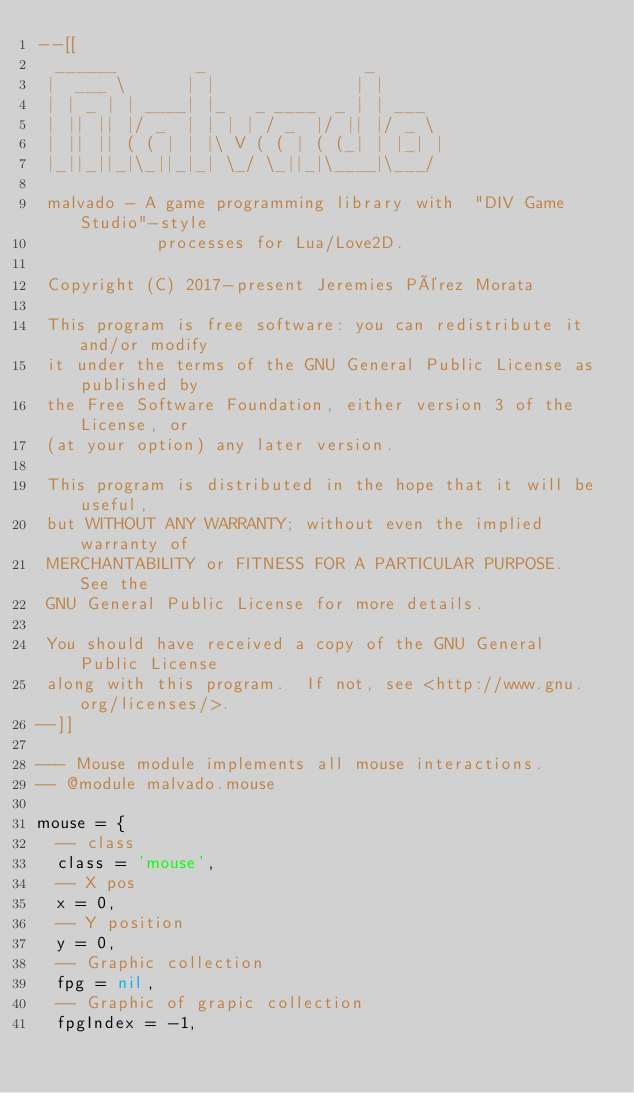<code> <loc_0><loc_0><loc_500><loc_500><_Lua_>--[[
  ______        _                _
 |  ___ \      | |              | |
 | | _ | | ____| |_   _ ____  _ | | ___
 | || || |/ _  | | | | / _  |/ || |/ _ \
 | || || ( ( | | |\ V ( ( | ( (_| | |_| |
 |_||_||_|\_||_|_| \_/ \_||_|\____|\___/

 malvado - A game programming library with  "DIV Game Studio"-style
            processes for Lua/Love2D.

 Copyright (C) 2017-present Jeremies Pérez Morata

 This program is free software: you can redistribute it and/or modify
 it under the terms of the GNU General Public License as published by
 the Free Software Foundation, either version 3 of the License, or
 (at your option) any later version.

 This program is distributed in the hope that it will be useful,
 but WITHOUT ANY WARRANTY; without even the implied warranty of
 MERCHANTABILITY or FITNESS FOR A PARTICULAR PURPOSE.  See the
 GNU General Public License for more details.

 You should have received a copy of the GNU General Public License
 along with this program.  If not, see <http://www.gnu.org/licenses/>.
--]]

--- Mouse module implements all mouse interactions.
-- @module malvado.mouse

mouse = {
  -- class
  class = 'mouse',
  -- X pos
  x = 0,
  -- Y position
  y = 0,
  -- Graphic collection
  fpg = nil,
  -- Graphic of grapic collection
  fpgIndex = -1,</code> 